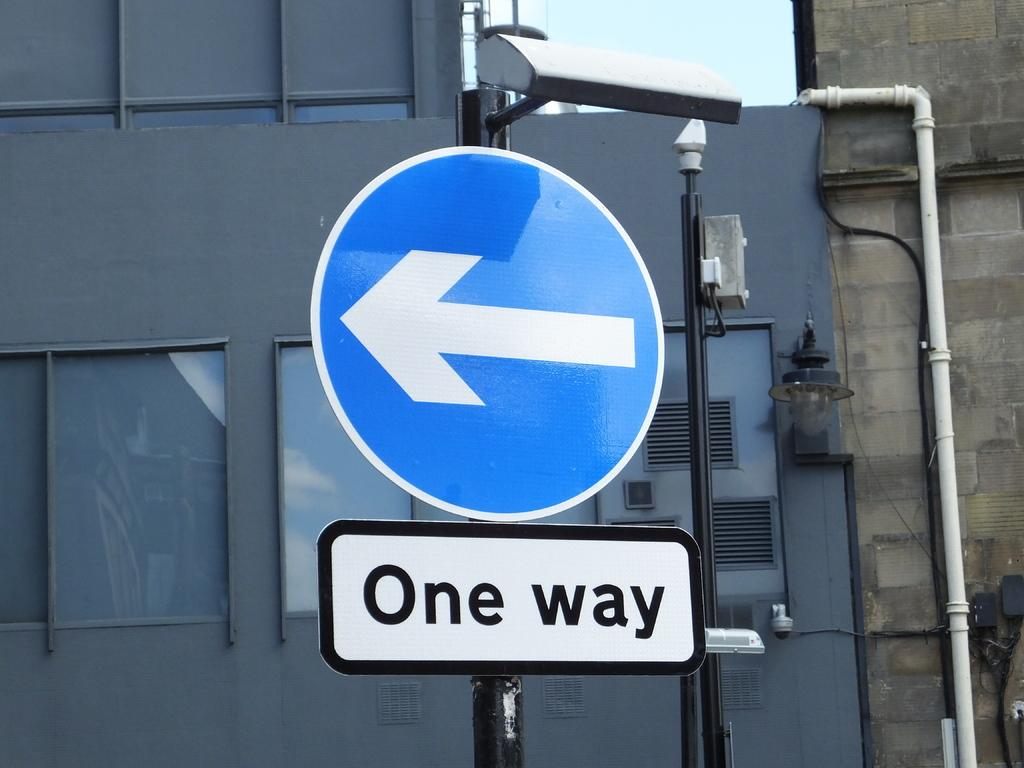<image>
Provide a brief description of the given image. A blue sign with a white arrow pointing left is labeled One way. 